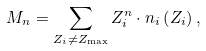Convert formula to latex. <formula><loc_0><loc_0><loc_500><loc_500>M _ { n } = \sum _ { Z _ { i } \neq Z _ { \max } } Z _ { i } ^ { n } \cdot n _ { i } \left ( Z _ { i } \right ) ,</formula> 